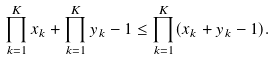<formula> <loc_0><loc_0><loc_500><loc_500>\prod _ { k = 1 } ^ { K } x _ { k } + \prod _ { k = 1 } ^ { K } y _ { k } - 1 \leq \prod _ { k = 1 } ^ { K } ( x _ { k } + y _ { k } - 1 ) .</formula> 